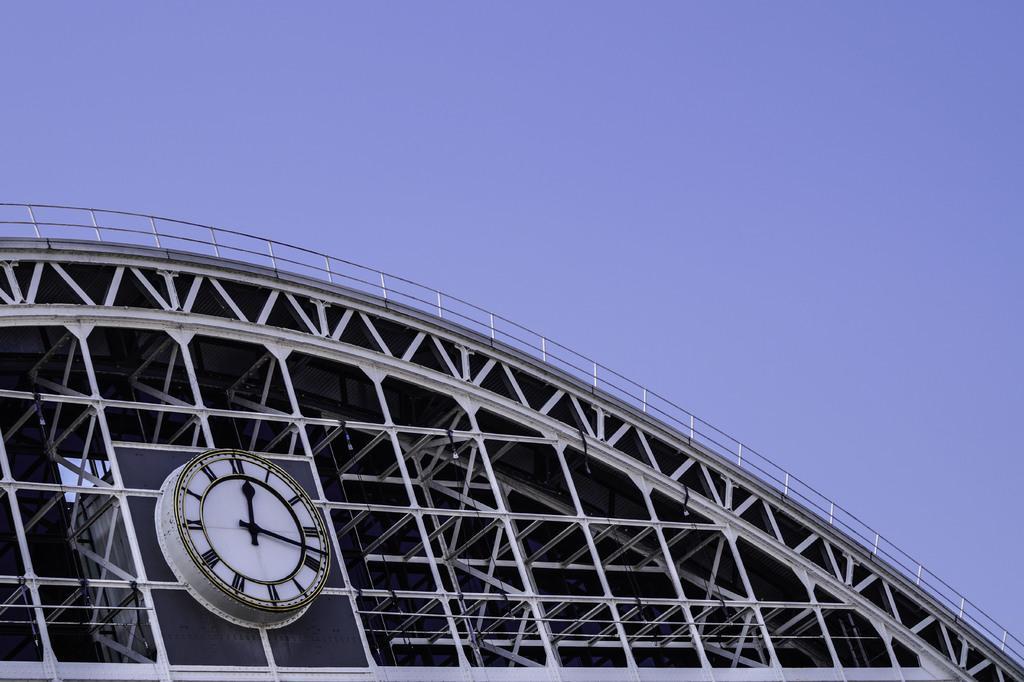Can you describe this image briefly? In this image there is the sky towards the top of the image, there is a building towards the bottom of the image, there is a clock on the building. 